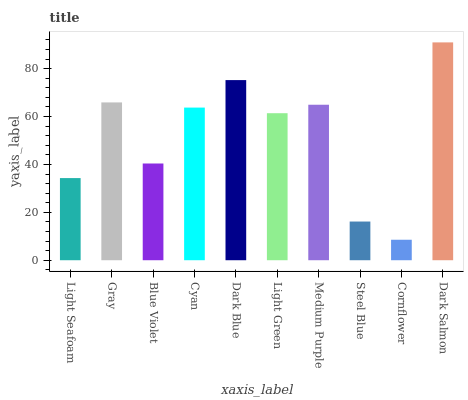Is Gray the minimum?
Answer yes or no. No. Is Gray the maximum?
Answer yes or no. No. Is Gray greater than Light Seafoam?
Answer yes or no. Yes. Is Light Seafoam less than Gray?
Answer yes or no. Yes. Is Light Seafoam greater than Gray?
Answer yes or no. No. Is Gray less than Light Seafoam?
Answer yes or no. No. Is Cyan the high median?
Answer yes or no. Yes. Is Light Green the low median?
Answer yes or no. Yes. Is Dark Blue the high median?
Answer yes or no. No. Is Cornflower the low median?
Answer yes or no. No. 